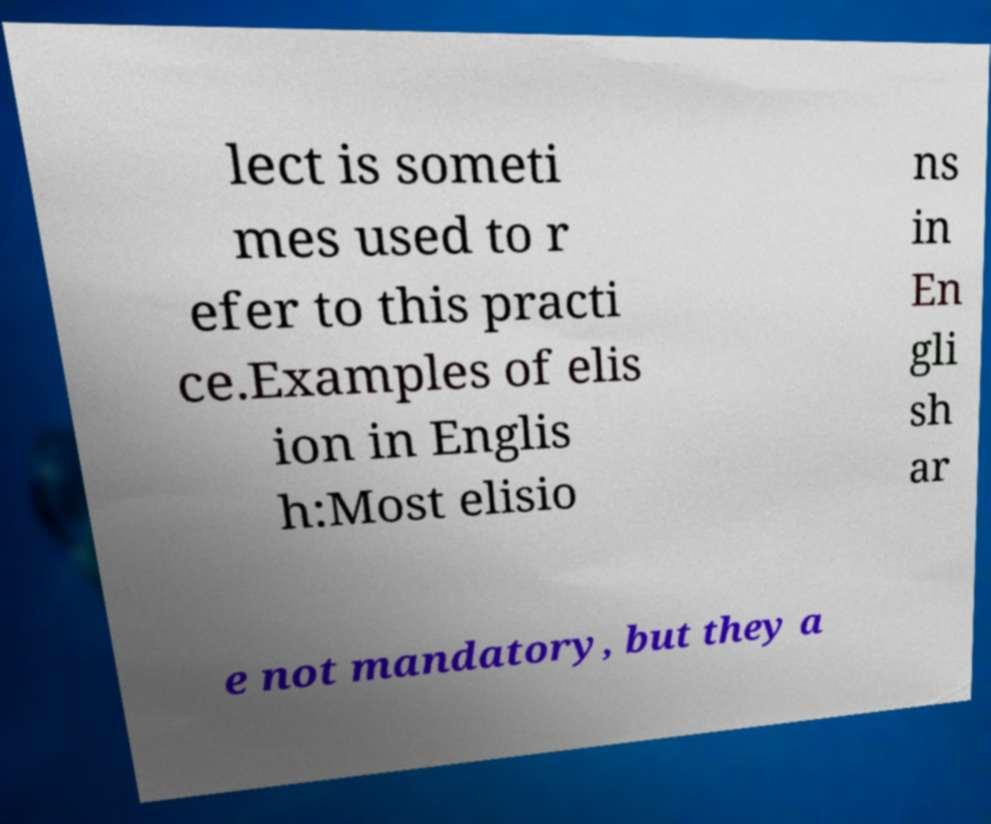What messages or text are displayed in this image? I need them in a readable, typed format. lect is someti mes used to r efer to this practi ce.Examples of elis ion in Englis h:Most elisio ns in En gli sh ar e not mandatory, but they a 